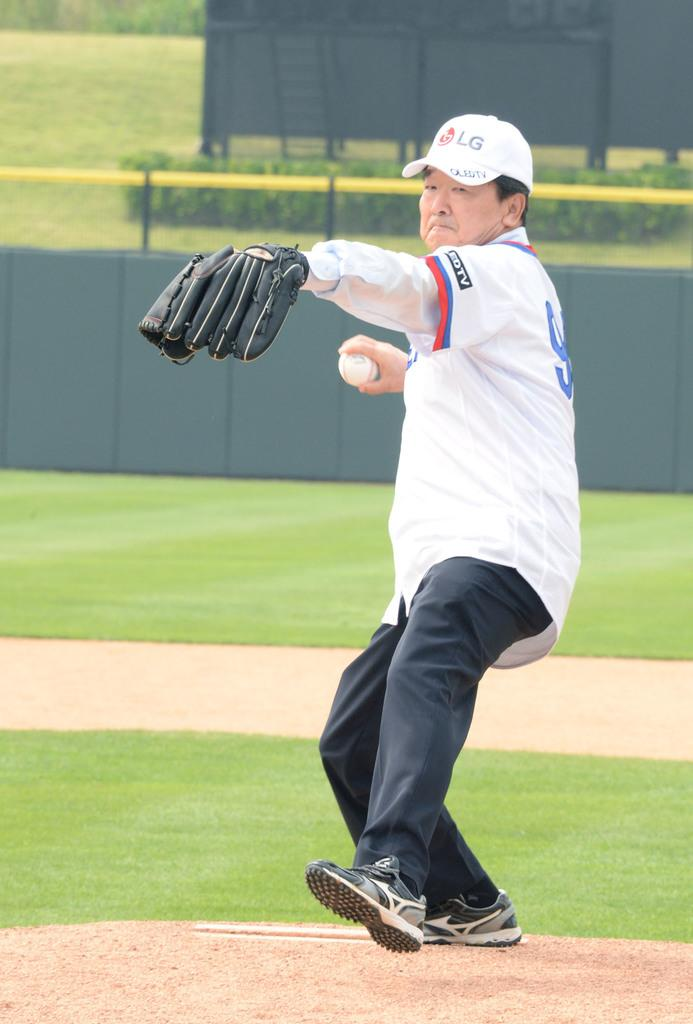<image>
Give a short and clear explanation of the subsequent image. The man pitching the ball is wearing a baseball cap with the logo for LG on the front. 